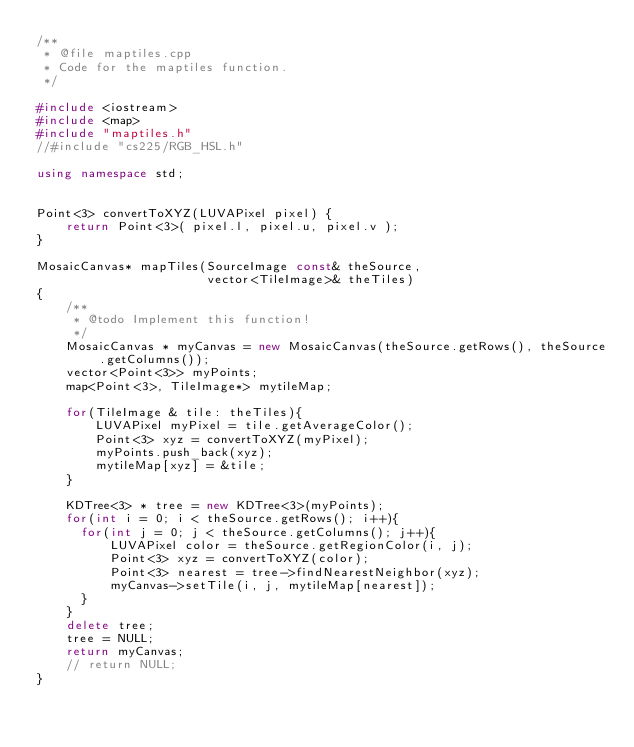<code> <loc_0><loc_0><loc_500><loc_500><_C++_>/**
 * @file maptiles.cpp
 * Code for the maptiles function.
 */

#include <iostream>
#include <map>
#include "maptiles.h"
//#include "cs225/RGB_HSL.h"

using namespace std;


Point<3> convertToXYZ(LUVAPixel pixel) {
    return Point<3>( pixel.l, pixel.u, pixel.v );
}

MosaicCanvas* mapTiles(SourceImage const& theSource,
                       vector<TileImage>& theTiles)
{
    /**
     * @todo Implement this function!
     */
    MosaicCanvas * myCanvas = new MosaicCanvas(theSource.getRows(), theSource.getColumns());
    vector<Point<3>> myPoints;
    map<Point<3>, TileImage*> mytileMap;

    for(TileImage & tile: theTiles){
        LUVAPixel myPixel = tile.getAverageColor();
        Point<3> xyz = convertToXYZ(myPixel);
        myPoints.push_back(xyz);
        mytileMap[xyz] = &tile;
    }

    KDTree<3> * tree = new KDTree<3>(myPoints);
    for(int i = 0; i < theSource.getRows(); i++){
      for(int j = 0; j < theSource.getColumns(); j++){
          LUVAPixel color = theSource.getRegionColor(i, j);
          Point<3> xyz = convertToXYZ(color);
          Point<3> nearest = tree->findNearestNeighbor(xyz);
          myCanvas->setTile(i, j, mytileMap[nearest]);
      }
    }
    delete tree;
    tree = NULL;
    return myCanvas;
    // return NULL;
}
</code> 